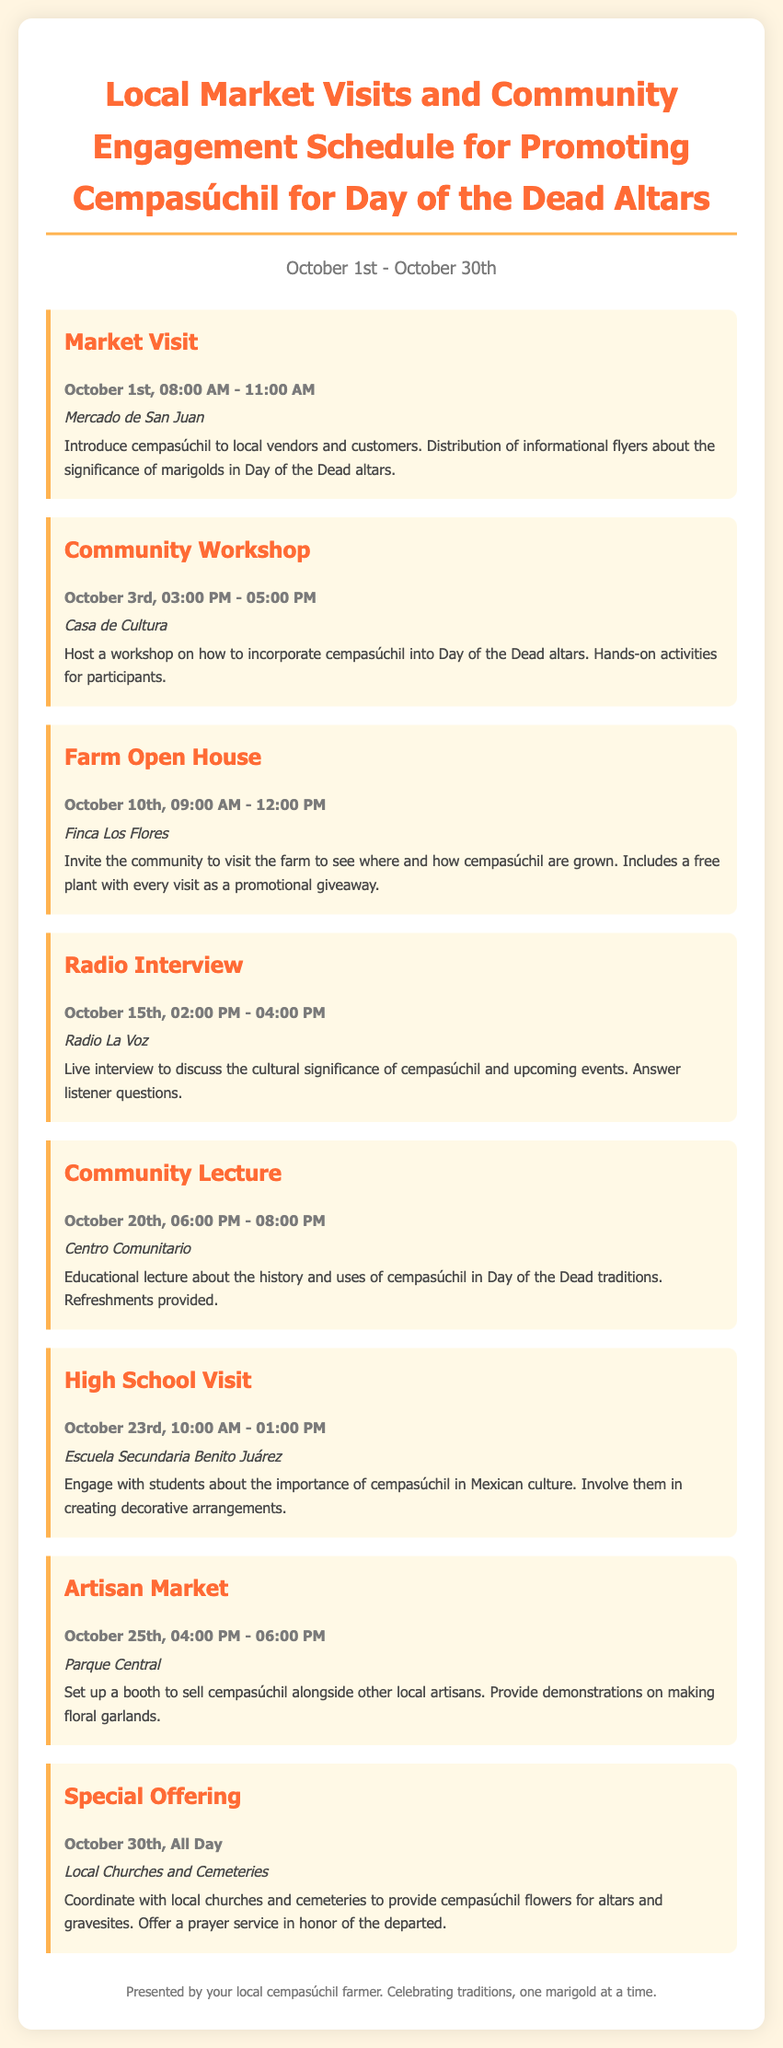What is the title of the itinerary? The title of the itinerary is presented prominently at the top of the document, which is a description of the planned activities.
Answer: Local Market Visits and Community Engagement Schedule for Promoting Cempasúchil for Day of the Dead Altars When does the itinerary take place? The date range provided in the document indicates the duration of the activities planned in the itinerary.
Answer: October 1st - October 30th What is the location of the Community Workshop? The specific location for the Community Workshop is mentioned in the itinerary under that activity's details.
Answer: Casa de Cultura How many activities are scheduled for this itinerary? To find the total number of activities, count the distinct activities listed in the itinerary.
Answer: 7 What is the date and time for the Farm Open House? The date and time detail is provided for the Farm Open House in the itinerary, specifying when it takes place.
Answer: October 10th, 09:00 AM - 12:00 PM Which activity involves high school students? The specific activity that engages high school students is highlighted in the itinerary information about engaging students.
Answer: High School Visit What event is scheduled for October 30th? The itinerary lists a special event that happens on this date, describing its significance in relation to the altars.
Answer: Special Offering 